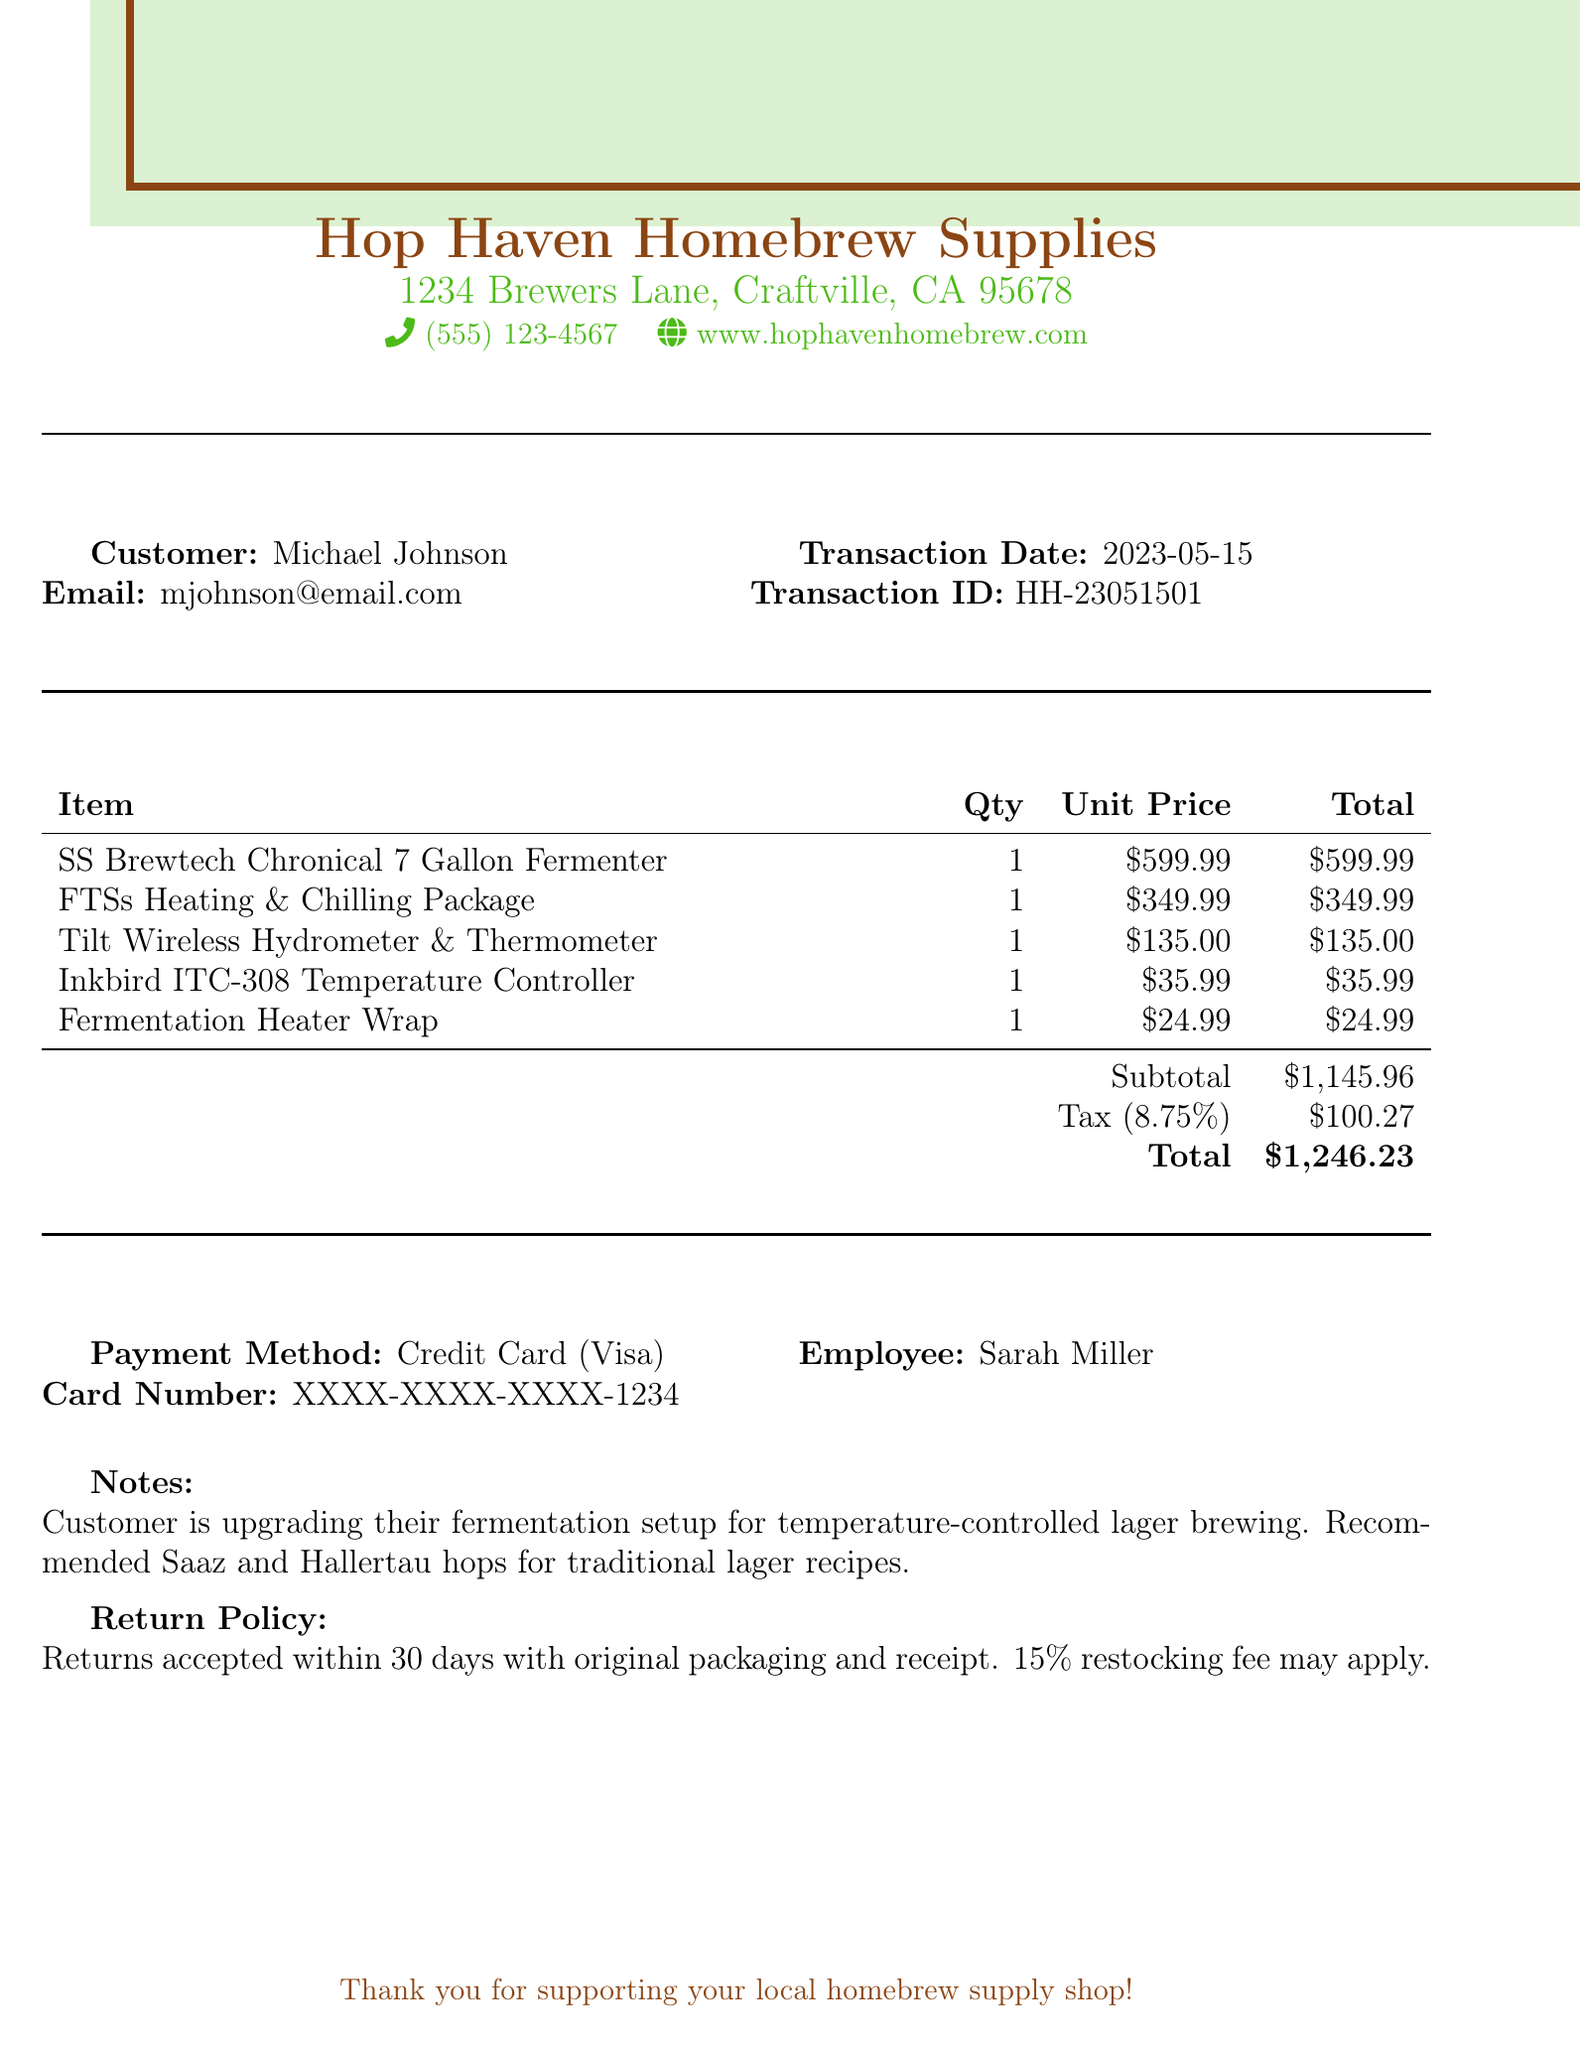What is the name of the shop? The shop name is listed at the top of the document, which is "Hop Haven Homebrew Supplies."
Answer: Hop Haven Homebrew Supplies Who is the customer? The customer's name is provided in the document, specifically listed after the heading "Customer:."
Answer: Michael Johnson What is the transaction date? The transaction date can be found under the section that records transaction details, listed as "Transaction Date."
Answer: 2023-05-15 What is the subtotal amount? The subtotal is explicitly stated in the transaction summary table, labeled as "Subtotal."
Answer: $1,145.96 How many items are listed in the transaction? Counting the items listed in the document shows there are five individual items purchased.
Answer: 5 Who processed the transaction? The employee who handled the transaction is noted in the document, specifically next to "Employee:."
Answer: Sarah Miller What is the return policy? The return policy details are summarized in the document under a specific section labeled "Return Policy."
Answer: Returns accepted within 30 days with original packaging and receipt. 15% restocking fee may apply What payment method was used? The payment method is included in the transaction details and listed as "Payment Method."
Answer: Credit Card (Visa) What is the total amount charged for the transaction? The total amount for the transaction is clearly stated in the summary table with "Total."
Answer: $1,246.23 